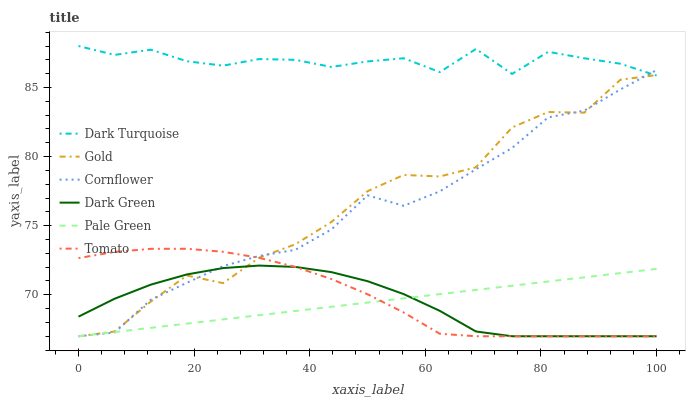Does Pale Green have the minimum area under the curve?
Answer yes or no. Yes. Does Dark Turquoise have the maximum area under the curve?
Answer yes or no. Yes. Does Cornflower have the minimum area under the curve?
Answer yes or no. No. Does Cornflower have the maximum area under the curve?
Answer yes or no. No. Is Pale Green the smoothest?
Answer yes or no. Yes. Is Gold the roughest?
Answer yes or no. Yes. Is Cornflower the smoothest?
Answer yes or no. No. Is Cornflower the roughest?
Answer yes or no. No. Does Tomato have the lowest value?
Answer yes or no. Yes. Does Dark Turquoise have the lowest value?
Answer yes or no. No. Does Dark Turquoise have the highest value?
Answer yes or no. Yes. Does Cornflower have the highest value?
Answer yes or no. No. Is Dark Green less than Dark Turquoise?
Answer yes or no. Yes. Is Dark Turquoise greater than Tomato?
Answer yes or no. Yes. Does Gold intersect Dark Green?
Answer yes or no. Yes. Is Gold less than Dark Green?
Answer yes or no. No. Is Gold greater than Dark Green?
Answer yes or no. No. Does Dark Green intersect Dark Turquoise?
Answer yes or no. No. 